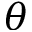<formula> <loc_0><loc_0><loc_500><loc_500>\theta</formula> 